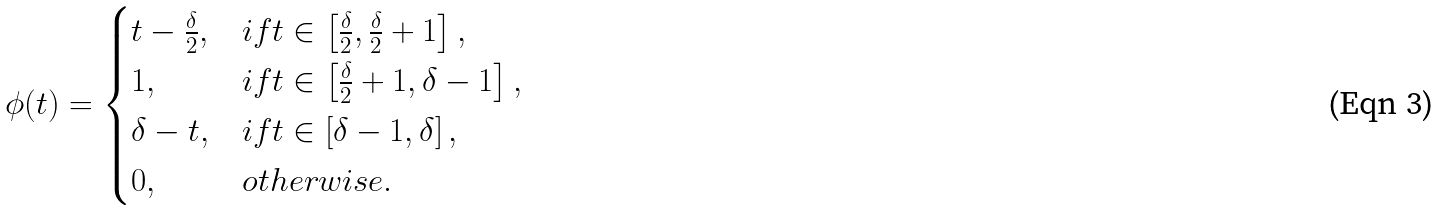Convert formula to latex. <formula><loc_0><loc_0><loc_500><loc_500>\phi ( t ) = \begin{cases} t - \frac { \delta } { 2 } , & i f t \in \left [ \frac { \delta } { 2 } , \frac { \delta } { 2 } + 1 \right ] , \\ 1 , & i f t \in \left [ \frac { \delta } { 2 } + 1 , \delta - 1 \right ] , \\ \delta - t , & i f t \in \left [ \delta - 1 , \delta \right ] , \\ 0 , & o t h e r w i s e . \end{cases}</formula> 